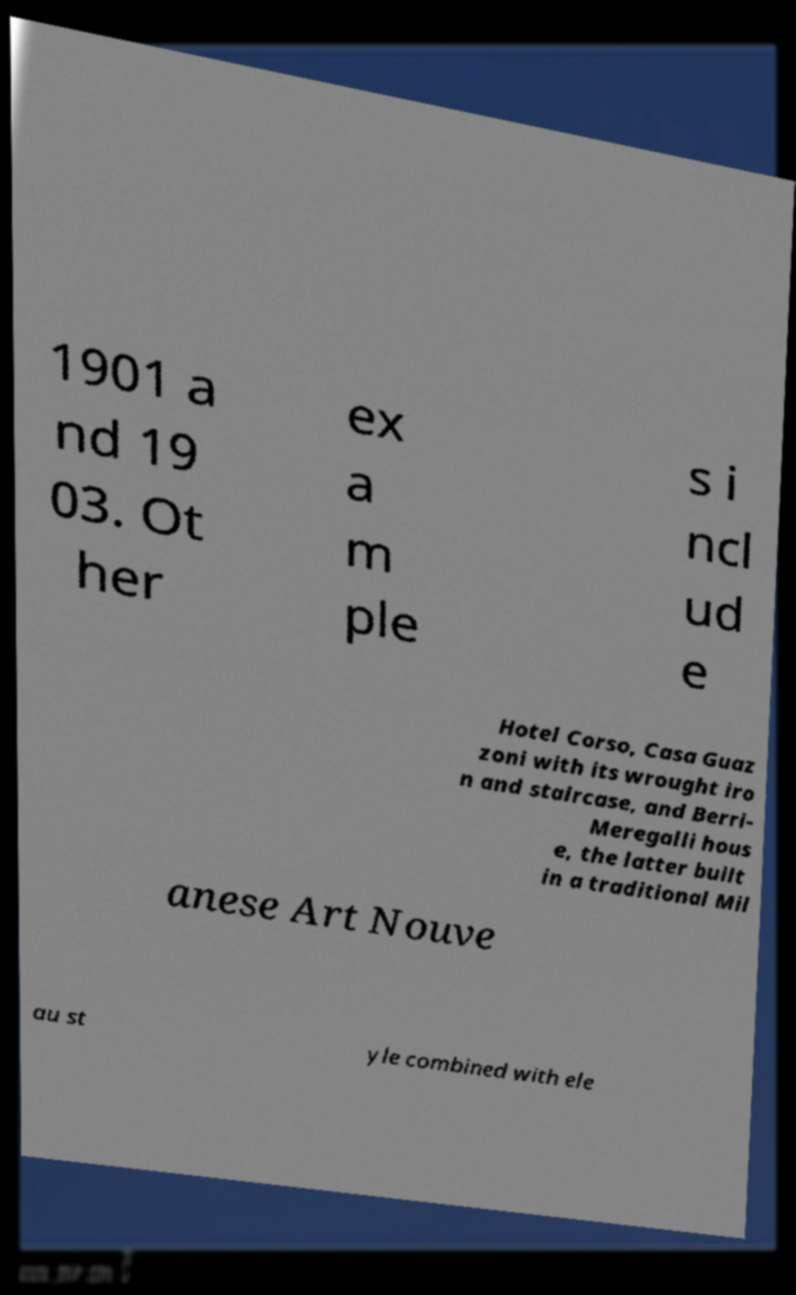I need the written content from this picture converted into text. Can you do that? 1901 a nd 19 03. Ot her ex a m ple s i ncl ud e Hotel Corso, Casa Guaz zoni with its wrought iro n and staircase, and Berri- Meregalli hous e, the latter built in a traditional Mil anese Art Nouve au st yle combined with ele 